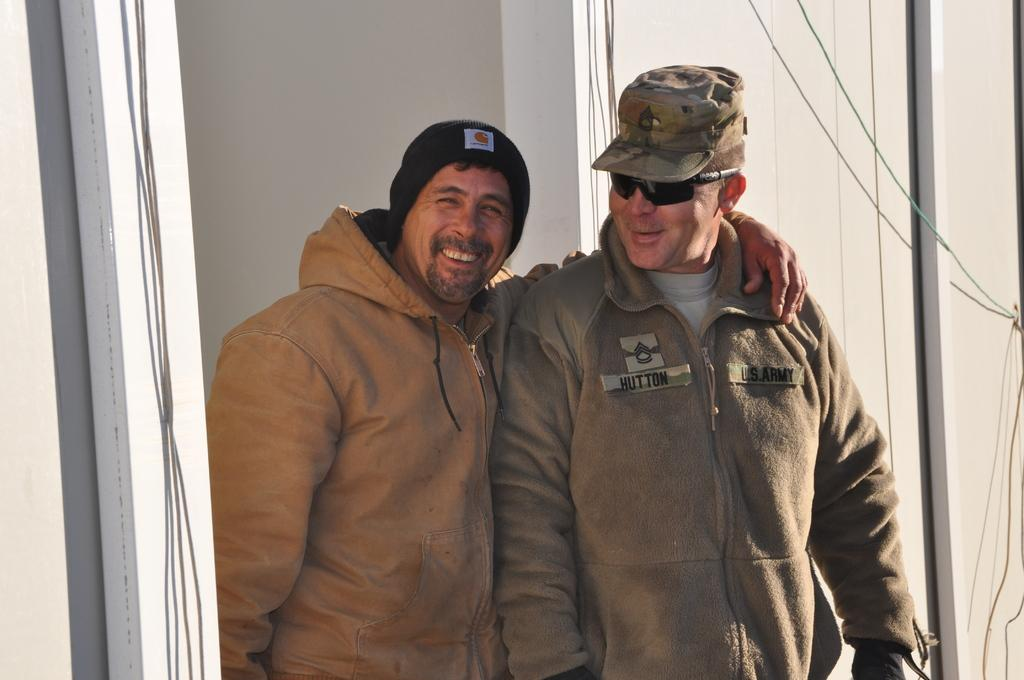How many people are in the image? There are persons in the image, but the exact number is not specified. What is behind the persons in the image? The persons are in front of a wall. What are the persons wearing on their heads? The persons are wearing caps. What are the persons wearing on their bodies? The persons are wearing clothes. What type of balloon can be seen floating near the persons in the image? There is no balloon present in the image. How many scarves are being worn by the persons in the image? The persons are wearing caps, not scarves, in the image. 